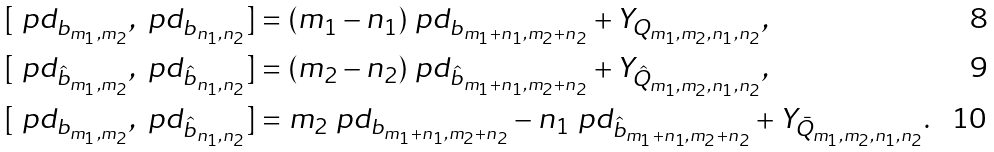Convert formula to latex. <formula><loc_0><loc_0><loc_500><loc_500>& [ \ p d _ { b _ { m _ { 1 } , m _ { 2 } } } , \ p d _ { b _ { n _ { 1 } , n _ { 2 } } } ] = ( m _ { 1 } - n _ { 1 } ) \ p d _ { b _ { m _ { 1 } + n _ { 1 } , m _ { 2 } + n _ { 2 } } } + Y _ { Q _ { m _ { 1 } , m _ { 2 } , n _ { 1 } , n _ { 2 } } } , \\ & [ \ p d _ { \hat { b } _ { m _ { 1 } , m _ { 2 } } } , \ p d _ { \hat { b } _ { n _ { 1 } , n _ { 2 } } } ] = ( m _ { 2 } - n _ { 2 } ) \ p d _ { \hat { b } _ { m _ { 1 } + n _ { 1 } , m _ { 2 } + n _ { 2 } } } + Y _ { \hat { Q } _ { m _ { 1 } , m _ { 2 } , n _ { 1 } , n _ { 2 } } } , \\ & [ \ p d _ { b _ { m _ { 1 } , m _ { 2 } } } , \ p d _ { \hat { b } _ { n _ { 1 } , n _ { 2 } } } ] = m _ { 2 } \ p d _ { b _ { m _ { 1 } + n _ { 1 } , m _ { 2 } + n _ { 2 } } } - n _ { 1 } \ p d _ { \hat { b } _ { m _ { 1 } + n _ { 1 } , m _ { 2 } + n _ { 2 } } } + Y _ { \bar { Q } _ { m _ { 1 } , m _ { 2 } , n _ { 1 } , n _ { 2 } } } .</formula> 